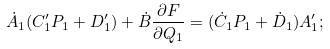<formula> <loc_0><loc_0><loc_500><loc_500>\dot { A } _ { 1 } ( C _ { 1 } ^ { \prime } P _ { 1 } + D _ { 1 } ^ { \prime } ) + \dot { B } \frac { \partial F } { \partial Q _ { 1 } } = ( \dot { C } _ { 1 } P _ { 1 } + \dot { D } _ { 1 } ) A ^ { \prime } _ { 1 } ;</formula> 